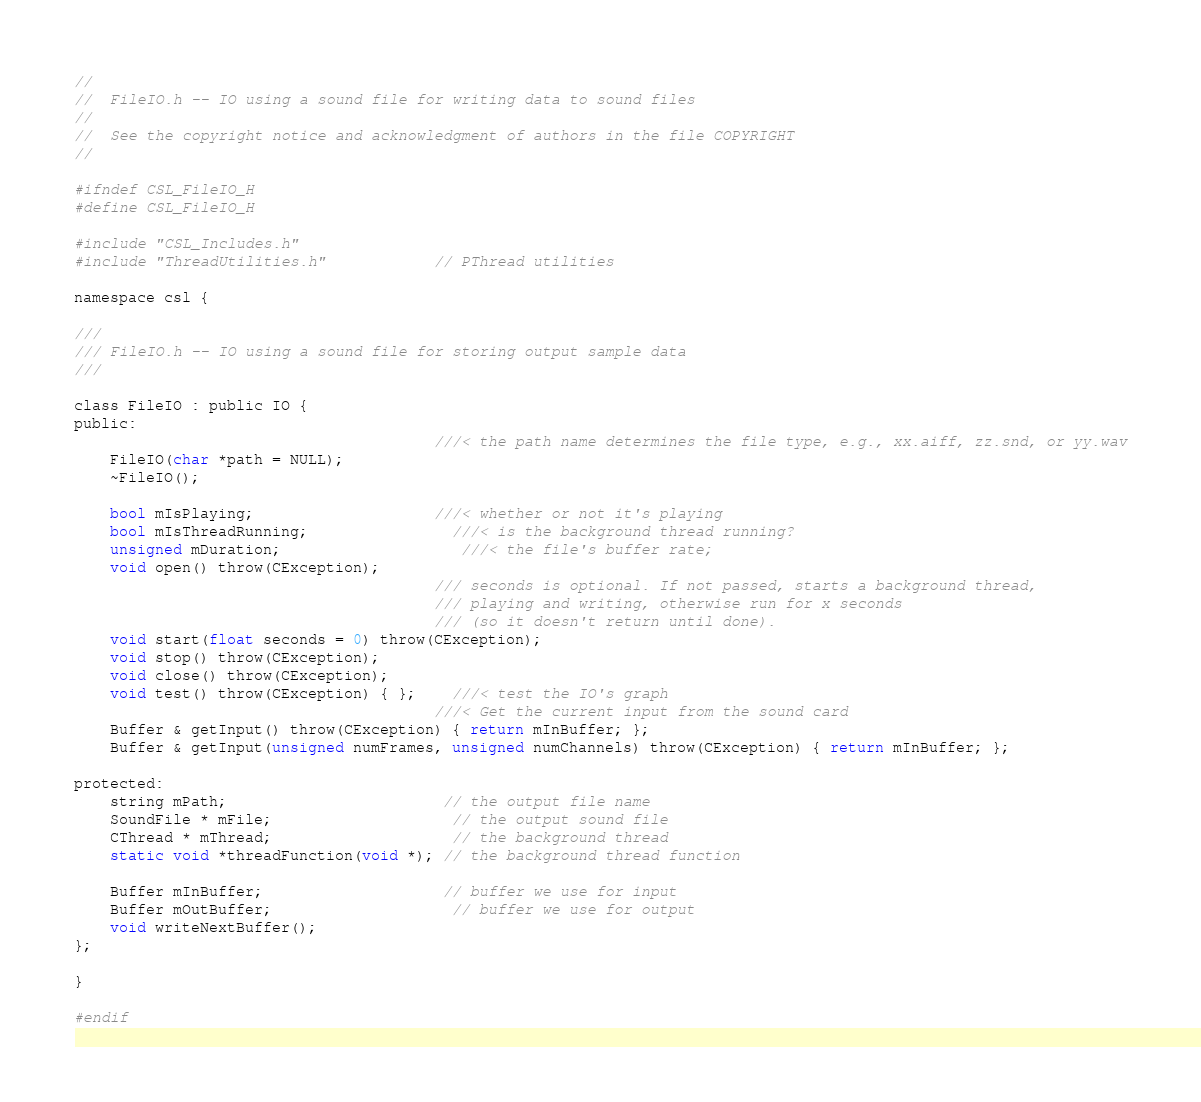Convert code to text. <code><loc_0><loc_0><loc_500><loc_500><_C_>//
//  FileIO.h -- IO using a sound file for writing data to sound files
//
//	See the copyright notice and acknowledgment of authors in the file COPYRIGHT
//

#ifndef CSL_FileIO_H
#define CSL_FileIO_H

#include "CSL_Includes.h"
#include "ThreadUtilities.h"			// PThread utilities

namespace csl {

///
/// FileIO.h -- IO using a sound file for storing output sample data
///

class FileIO : public IO {
public:
										///< the path name determines the file type, e.g., xx.aiff, zz.snd, or yy.wav
	FileIO(char *path = NULL);
	~FileIO();

	bool mIsPlaying;					///< whether or not it's playing
	bool mIsThreadRunning;				///< is the background thread running?
	unsigned mDuration;					///< the file's buffer rate;
	void open() throw(CException);
										/// seconds is optional. If not passed, starts a background thread, 
										/// playing and writing, otherwise run for x seconds
										/// (so it doesn't return until done).
	void start(float seconds = 0) throw(CException);
	void stop() throw(CException);
	void close() throw(CException);
	void test() throw(CException) { };	///< test the IO's graph
										///< Get the current input from the sound card
	Buffer & getInput() throw(CException) { return mInBuffer; };
	Buffer & getInput(unsigned numFrames, unsigned numChannels) throw(CException) { return mInBuffer; };

protected:
	string mPath;						// the output file name
	SoundFile * mFile;					// the output sound file
	CThread * mThread;					// the background thread
	static void *threadFunction(void *); // the background thread function

	Buffer mInBuffer;					// buffer we use for input
	Buffer mOutBuffer;					// buffer we use for output
	void writeNextBuffer();
};

}

#endif
</code> 